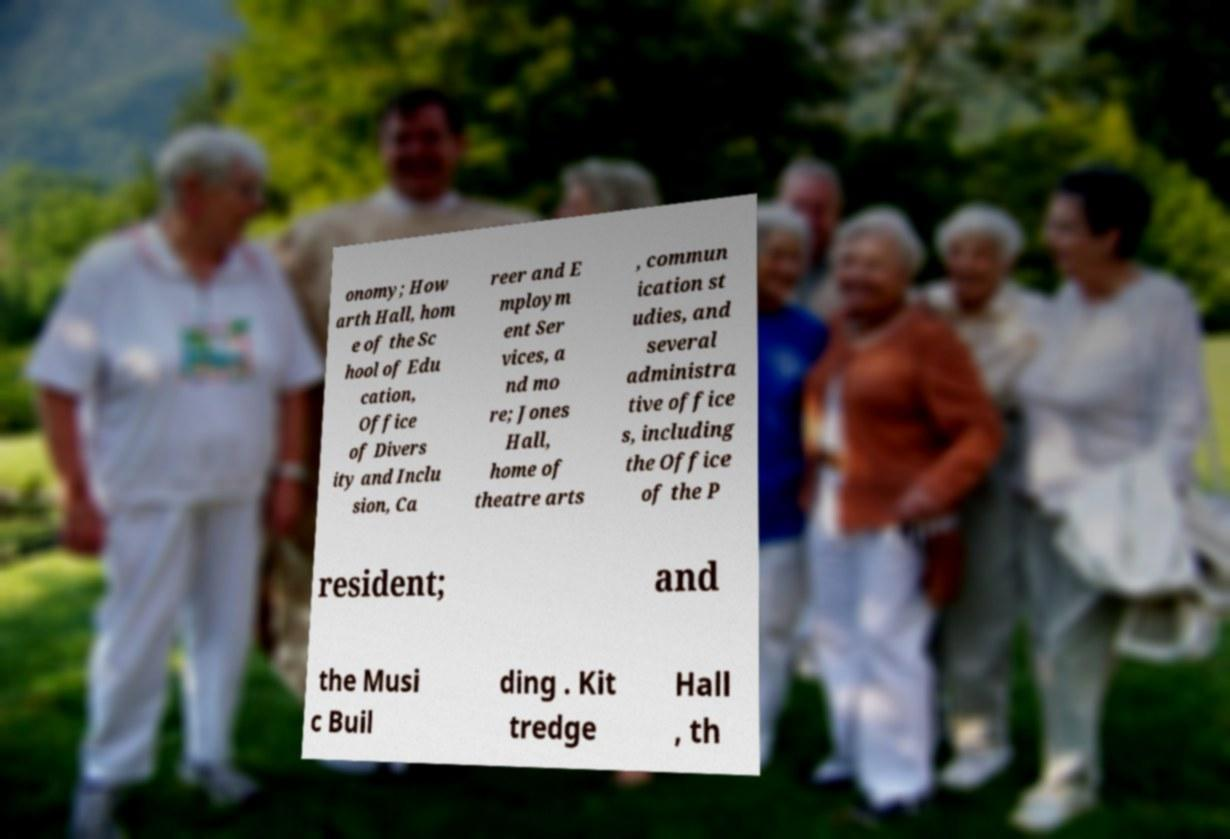Please identify and transcribe the text found in this image. onomy; How arth Hall, hom e of the Sc hool of Edu cation, Office of Divers ity and Inclu sion, Ca reer and E mploym ent Ser vices, a nd mo re; Jones Hall, home of theatre arts , commun ication st udies, and several administra tive office s, including the Office of the P resident; and the Musi c Buil ding . Kit tredge Hall , th 